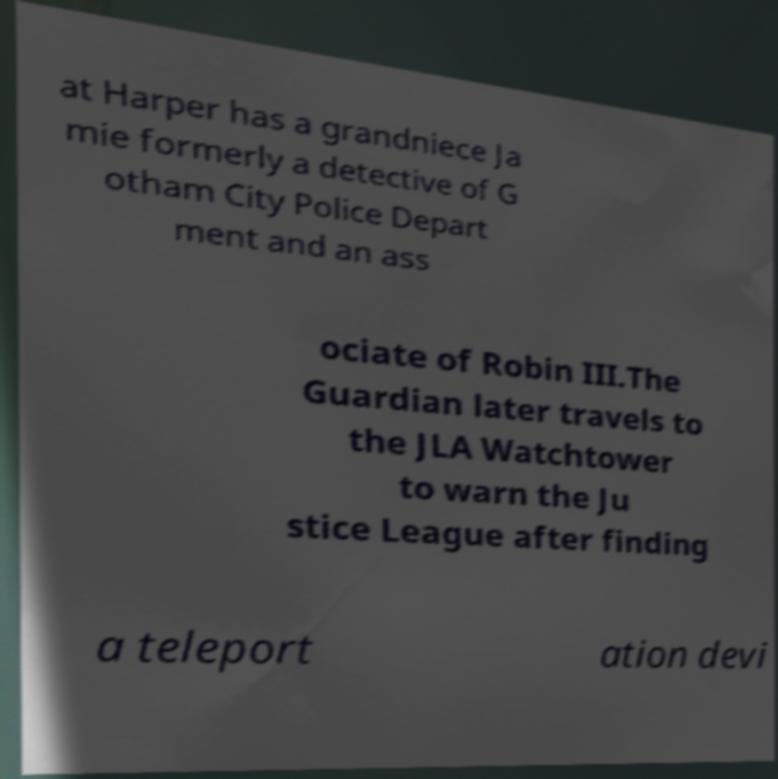Can you read and provide the text displayed in the image?This photo seems to have some interesting text. Can you extract and type it out for me? at Harper has a grandniece Ja mie formerly a detective of G otham City Police Depart ment and an ass ociate of Robin III.The Guardian later travels to the JLA Watchtower to warn the Ju stice League after finding a teleport ation devi 